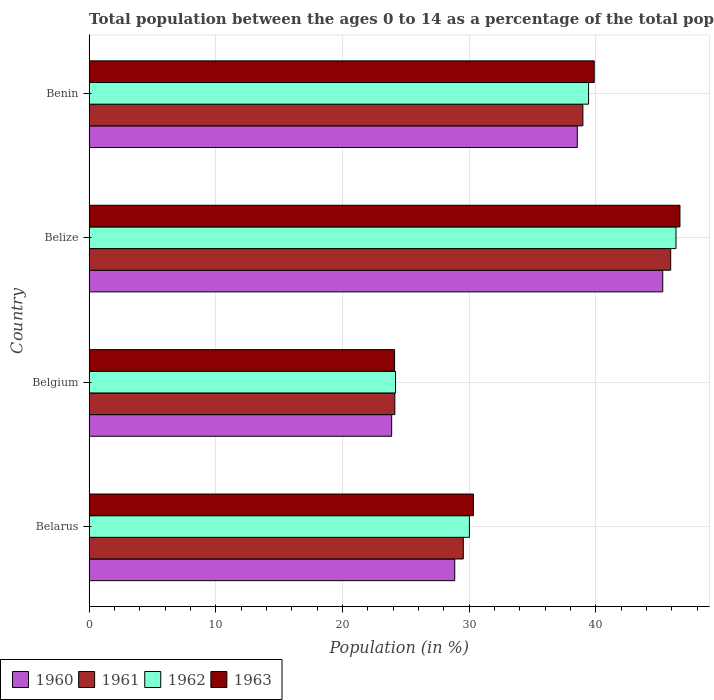How many groups of bars are there?
Your answer should be very brief. 4. Are the number of bars on each tick of the Y-axis equal?
Your response must be concise. Yes. How many bars are there on the 2nd tick from the top?
Make the answer very short. 4. What is the label of the 2nd group of bars from the top?
Make the answer very short. Belize. In how many cases, is the number of bars for a given country not equal to the number of legend labels?
Your answer should be very brief. 0. What is the percentage of the population ages 0 to 14 in 1960 in Belgium?
Ensure brevity in your answer.  23.88. Across all countries, what is the maximum percentage of the population ages 0 to 14 in 1961?
Your response must be concise. 45.9. Across all countries, what is the minimum percentage of the population ages 0 to 14 in 1961?
Your answer should be very brief. 24.13. In which country was the percentage of the population ages 0 to 14 in 1963 maximum?
Ensure brevity in your answer.  Belize. In which country was the percentage of the population ages 0 to 14 in 1960 minimum?
Make the answer very short. Belgium. What is the total percentage of the population ages 0 to 14 in 1963 in the graph?
Keep it short and to the point. 140.95. What is the difference between the percentage of the population ages 0 to 14 in 1960 in Belgium and that in Benin?
Your answer should be very brief. -14.65. What is the difference between the percentage of the population ages 0 to 14 in 1960 in Benin and the percentage of the population ages 0 to 14 in 1963 in Belize?
Your answer should be very brief. -8.1. What is the average percentage of the population ages 0 to 14 in 1962 per country?
Your answer should be very brief. 34.99. What is the difference between the percentage of the population ages 0 to 14 in 1961 and percentage of the population ages 0 to 14 in 1962 in Belarus?
Provide a short and direct response. -0.48. In how many countries, is the percentage of the population ages 0 to 14 in 1961 greater than 18 ?
Provide a short and direct response. 4. What is the ratio of the percentage of the population ages 0 to 14 in 1962 in Belize to that in Benin?
Offer a very short reply. 1.18. Is the percentage of the population ages 0 to 14 in 1962 in Belgium less than that in Benin?
Your response must be concise. Yes. Is the difference between the percentage of the population ages 0 to 14 in 1961 in Belgium and Benin greater than the difference between the percentage of the population ages 0 to 14 in 1962 in Belgium and Benin?
Your answer should be very brief. Yes. What is the difference between the highest and the second highest percentage of the population ages 0 to 14 in 1963?
Make the answer very short. 6.77. What is the difference between the highest and the lowest percentage of the population ages 0 to 14 in 1963?
Your answer should be compact. 22.52. Is the sum of the percentage of the population ages 0 to 14 in 1961 in Belarus and Benin greater than the maximum percentage of the population ages 0 to 14 in 1960 across all countries?
Your response must be concise. Yes. Is it the case that in every country, the sum of the percentage of the population ages 0 to 14 in 1963 and percentage of the population ages 0 to 14 in 1960 is greater than the sum of percentage of the population ages 0 to 14 in 1961 and percentage of the population ages 0 to 14 in 1962?
Give a very brief answer. No. What does the 4th bar from the bottom in Benin represents?
Offer a terse response. 1963. Is it the case that in every country, the sum of the percentage of the population ages 0 to 14 in 1963 and percentage of the population ages 0 to 14 in 1961 is greater than the percentage of the population ages 0 to 14 in 1960?
Offer a very short reply. Yes. How many bars are there?
Provide a succinct answer. 16. Are all the bars in the graph horizontal?
Provide a short and direct response. Yes. How many countries are there in the graph?
Make the answer very short. 4. Does the graph contain any zero values?
Ensure brevity in your answer.  No. Does the graph contain grids?
Give a very brief answer. Yes. Where does the legend appear in the graph?
Make the answer very short. Bottom left. What is the title of the graph?
Ensure brevity in your answer.  Total population between the ages 0 to 14 as a percentage of the total population. What is the label or title of the X-axis?
Offer a terse response. Population (in %). What is the label or title of the Y-axis?
Ensure brevity in your answer.  Country. What is the Population (in %) of 1960 in Belarus?
Offer a very short reply. 28.86. What is the Population (in %) of 1961 in Belarus?
Your answer should be compact. 29.54. What is the Population (in %) in 1962 in Belarus?
Keep it short and to the point. 30.02. What is the Population (in %) in 1963 in Belarus?
Provide a short and direct response. 30.34. What is the Population (in %) in 1960 in Belgium?
Give a very brief answer. 23.88. What is the Population (in %) in 1961 in Belgium?
Ensure brevity in your answer.  24.13. What is the Population (in %) of 1962 in Belgium?
Provide a succinct answer. 24.19. What is the Population (in %) of 1963 in Belgium?
Provide a short and direct response. 24.11. What is the Population (in %) of 1960 in Belize?
Give a very brief answer. 45.28. What is the Population (in %) of 1961 in Belize?
Provide a succinct answer. 45.9. What is the Population (in %) of 1962 in Belize?
Ensure brevity in your answer.  46.32. What is the Population (in %) in 1963 in Belize?
Keep it short and to the point. 46.63. What is the Population (in %) of 1960 in Benin?
Provide a succinct answer. 38.53. What is the Population (in %) in 1961 in Benin?
Your response must be concise. 38.97. What is the Population (in %) of 1962 in Benin?
Your answer should be compact. 39.42. What is the Population (in %) of 1963 in Benin?
Keep it short and to the point. 39.87. Across all countries, what is the maximum Population (in %) of 1960?
Provide a short and direct response. 45.28. Across all countries, what is the maximum Population (in %) of 1961?
Make the answer very short. 45.9. Across all countries, what is the maximum Population (in %) in 1962?
Offer a very short reply. 46.32. Across all countries, what is the maximum Population (in %) in 1963?
Make the answer very short. 46.63. Across all countries, what is the minimum Population (in %) in 1960?
Provide a short and direct response. 23.88. Across all countries, what is the minimum Population (in %) of 1961?
Make the answer very short. 24.13. Across all countries, what is the minimum Population (in %) in 1962?
Keep it short and to the point. 24.19. Across all countries, what is the minimum Population (in %) of 1963?
Offer a very short reply. 24.11. What is the total Population (in %) of 1960 in the graph?
Offer a very short reply. 136.55. What is the total Population (in %) in 1961 in the graph?
Ensure brevity in your answer.  138.54. What is the total Population (in %) of 1962 in the graph?
Keep it short and to the point. 139.95. What is the total Population (in %) in 1963 in the graph?
Provide a short and direct response. 140.95. What is the difference between the Population (in %) of 1960 in Belarus and that in Belgium?
Your answer should be very brief. 4.98. What is the difference between the Population (in %) in 1961 in Belarus and that in Belgium?
Provide a succinct answer. 5.41. What is the difference between the Population (in %) of 1962 in Belarus and that in Belgium?
Ensure brevity in your answer.  5.83. What is the difference between the Population (in %) in 1963 in Belarus and that in Belgium?
Make the answer very short. 6.22. What is the difference between the Population (in %) in 1960 in Belarus and that in Belize?
Your response must be concise. -16.41. What is the difference between the Population (in %) of 1961 in Belarus and that in Belize?
Offer a very short reply. -16.37. What is the difference between the Population (in %) in 1962 in Belarus and that in Belize?
Make the answer very short. -16.3. What is the difference between the Population (in %) in 1963 in Belarus and that in Belize?
Your response must be concise. -16.3. What is the difference between the Population (in %) in 1960 in Belarus and that in Benin?
Offer a terse response. -9.67. What is the difference between the Population (in %) of 1961 in Belarus and that in Benin?
Make the answer very short. -9.44. What is the difference between the Population (in %) of 1962 in Belarus and that in Benin?
Ensure brevity in your answer.  -9.4. What is the difference between the Population (in %) in 1963 in Belarus and that in Benin?
Ensure brevity in your answer.  -9.53. What is the difference between the Population (in %) of 1960 in Belgium and that in Belize?
Make the answer very short. -21.39. What is the difference between the Population (in %) in 1961 in Belgium and that in Belize?
Your response must be concise. -21.77. What is the difference between the Population (in %) in 1962 in Belgium and that in Belize?
Your answer should be compact. -22.14. What is the difference between the Population (in %) in 1963 in Belgium and that in Belize?
Give a very brief answer. -22.52. What is the difference between the Population (in %) of 1960 in Belgium and that in Benin?
Your answer should be very brief. -14.65. What is the difference between the Population (in %) of 1961 in Belgium and that in Benin?
Your answer should be compact. -14.84. What is the difference between the Population (in %) in 1962 in Belgium and that in Benin?
Your answer should be very brief. -15.24. What is the difference between the Population (in %) of 1963 in Belgium and that in Benin?
Offer a very short reply. -15.76. What is the difference between the Population (in %) in 1960 in Belize and that in Benin?
Provide a short and direct response. 6.74. What is the difference between the Population (in %) of 1961 in Belize and that in Benin?
Provide a succinct answer. 6.93. What is the difference between the Population (in %) in 1962 in Belize and that in Benin?
Offer a very short reply. 6.9. What is the difference between the Population (in %) in 1963 in Belize and that in Benin?
Your answer should be very brief. 6.77. What is the difference between the Population (in %) of 1960 in Belarus and the Population (in %) of 1961 in Belgium?
Your answer should be very brief. 4.73. What is the difference between the Population (in %) in 1960 in Belarus and the Population (in %) in 1962 in Belgium?
Keep it short and to the point. 4.67. What is the difference between the Population (in %) of 1960 in Belarus and the Population (in %) of 1963 in Belgium?
Provide a succinct answer. 4.75. What is the difference between the Population (in %) in 1961 in Belarus and the Population (in %) in 1962 in Belgium?
Give a very brief answer. 5.35. What is the difference between the Population (in %) in 1961 in Belarus and the Population (in %) in 1963 in Belgium?
Your answer should be very brief. 5.42. What is the difference between the Population (in %) in 1962 in Belarus and the Population (in %) in 1963 in Belgium?
Your response must be concise. 5.91. What is the difference between the Population (in %) of 1960 in Belarus and the Population (in %) of 1961 in Belize?
Your answer should be very brief. -17.04. What is the difference between the Population (in %) in 1960 in Belarus and the Population (in %) in 1962 in Belize?
Provide a succinct answer. -17.46. What is the difference between the Population (in %) in 1960 in Belarus and the Population (in %) in 1963 in Belize?
Make the answer very short. -17.77. What is the difference between the Population (in %) in 1961 in Belarus and the Population (in %) in 1962 in Belize?
Keep it short and to the point. -16.79. What is the difference between the Population (in %) in 1961 in Belarus and the Population (in %) in 1963 in Belize?
Your answer should be very brief. -17.1. What is the difference between the Population (in %) in 1962 in Belarus and the Population (in %) in 1963 in Belize?
Ensure brevity in your answer.  -16.62. What is the difference between the Population (in %) of 1960 in Belarus and the Population (in %) of 1961 in Benin?
Keep it short and to the point. -10.11. What is the difference between the Population (in %) in 1960 in Belarus and the Population (in %) in 1962 in Benin?
Give a very brief answer. -10.56. What is the difference between the Population (in %) of 1960 in Belarus and the Population (in %) of 1963 in Benin?
Your response must be concise. -11.01. What is the difference between the Population (in %) of 1961 in Belarus and the Population (in %) of 1962 in Benin?
Offer a terse response. -9.89. What is the difference between the Population (in %) of 1961 in Belarus and the Population (in %) of 1963 in Benin?
Provide a short and direct response. -10.33. What is the difference between the Population (in %) of 1962 in Belarus and the Population (in %) of 1963 in Benin?
Make the answer very short. -9.85. What is the difference between the Population (in %) of 1960 in Belgium and the Population (in %) of 1961 in Belize?
Your answer should be compact. -22.02. What is the difference between the Population (in %) of 1960 in Belgium and the Population (in %) of 1962 in Belize?
Your answer should be compact. -22.44. What is the difference between the Population (in %) in 1960 in Belgium and the Population (in %) in 1963 in Belize?
Provide a short and direct response. -22.75. What is the difference between the Population (in %) in 1961 in Belgium and the Population (in %) in 1962 in Belize?
Your answer should be very brief. -22.19. What is the difference between the Population (in %) of 1961 in Belgium and the Population (in %) of 1963 in Belize?
Keep it short and to the point. -22.5. What is the difference between the Population (in %) of 1962 in Belgium and the Population (in %) of 1963 in Belize?
Give a very brief answer. -22.45. What is the difference between the Population (in %) in 1960 in Belgium and the Population (in %) in 1961 in Benin?
Provide a succinct answer. -15.09. What is the difference between the Population (in %) of 1960 in Belgium and the Population (in %) of 1962 in Benin?
Your response must be concise. -15.54. What is the difference between the Population (in %) in 1960 in Belgium and the Population (in %) in 1963 in Benin?
Provide a short and direct response. -15.99. What is the difference between the Population (in %) of 1961 in Belgium and the Population (in %) of 1962 in Benin?
Your answer should be compact. -15.29. What is the difference between the Population (in %) in 1961 in Belgium and the Population (in %) in 1963 in Benin?
Offer a terse response. -15.74. What is the difference between the Population (in %) in 1962 in Belgium and the Population (in %) in 1963 in Benin?
Keep it short and to the point. -15.68. What is the difference between the Population (in %) in 1960 in Belize and the Population (in %) in 1961 in Benin?
Your answer should be very brief. 6.3. What is the difference between the Population (in %) in 1960 in Belize and the Population (in %) in 1962 in Benin?
Ensure brevity in your answer.  5.85. What is the difference between the Population (in %) in 1960 in Belize and the Population (in %) in 1963 in Benin?
Ensure brevity in your answer.  5.41. What is the difference between the Population (in %) of 1961 in Belize and the Population (in %) of 1962 in Benin?
Give a very brief answer. 6.48. What is the difference between the Population (in %) of 1961 in Belize and the Population (in %) of 1963 in Benin?
Your response must be concise. 6.03. What is the difference between the Population (in %) of 1962 in Belize and the Population (in %) of 1963 in Benin?
Provide a short and direct response. 6.45. What is the average Population (in %) of 1960 per country?
Give a very brief answer. 34.14. What is the average Population (in %) in 1961 per country?
Make the answer very short. 34.64. What is the average Population (in %) in 1962 per country?
Keep it short and to the point. 34.99. What is the average Population (in %) in 1963 per country?
Your answer should be very brief. 35.24. What is the difference between the Population (in %) of 1960 and Population (in %) of 1961 in Belarus?
Your answer should be very brief. -0.68. What is the difference between the Population (in %) in 1960 and Population (in %) in 1962 in Belarus?
Provide a short and direct response. -1.16. What is the difference between the Population (in %) in 1960 and Population (in %) in 1963 in Belarus?
Offer a terse response. -1.48. What is the difference between the Population (in %) of 1961 and Population (in %) of 1962 in Belarus?
Provide a short and direct response. -0.48. What is the difference between the Population (in %) in 1961 and Population (in %) in 1963 in Belarus?
Offer a very short reply. -0.8. What is the difference between the Population (in %) of 1962 and Population (in %) of 1963 in Belarus?
Ensure brevity in your answer.  -0.32. What is the difference between the Population (in %) in 1960 and Population (in %) in 1961 in Belgium?
Give a very brief answer. -0.25. What is the difference between the Population (in %) in 1960 and Population (in %) in 1962 in Belgium?
Give a very brief answer. -0.31. What is the difference between the Population (in %) in 1960 and Population (in %) in 1963 in Belgium?
Give a very brief answer. -0.23. What is the difference between the Population (in %) of 1961 and Population (in %) of 1962 in Belgium?
Give a very brief answer. -0.06. What is the difference between the Population (in %) in 1961 and Population (in %) in 1963 in Belgium?
Provide a succinct answer. 0.02. What is the difference between the Population (in %) in 1962 and Population (in %) in 1963 in Belgium?
Give a very brief answer. 0.07. What is the difference between the Population (in %) in 1960 and Population (in %) in 1961 in Belize?
Offer a very short reply. -0.63. What is the difference between the Population (in %) in 1960 and Population (in %) in 1962 in Belize?
Provide a succinct answer. -1.05. What is the difference between the Population (in %) of 1960 and Population (in %) of 1963 in Belize?
Provide a succinct answer. -1.36. What is the difference between the Population (in %) in 1961 and Population (in %) in 1962 in Belize?
Your answer should be compact. -0.42. What is the difference between the Population (in %) in 1961 and Population (in %) in 1963 in Belize?
Make the answer very short. -0.73. What is the difference between the Population (in %) in 1962 and Population (in %) in 1963 in Belize?
Keep it short and to the point. -0.31. What is the difference between the Population (in %) of 1960 and Population (in %) of 1961 in Benin?
Offer a terse response. -0.44. What is the difference between the Population (in %) in 1960 and Population (in %) in 1962 in Benin?
Give a very brief answer. -0.89. What is the difference between the Population (in %) of 1960 and Population (in %) of 1963 in Benin?
Give a very brief answer. -1.34. What is the difference between the Population (in %) of 1961 and Population (in %) of 1962 in Benin?
Your answer should be compact. -0.45. What is the difference between the Population (in %) of 1961 and Population (in %) of 1963 in Benin?
Provide a short and direct response. -0.9. What is the difference between the Population (in %) of 1962 and Population (in %) of 1963 in Benin?
Offer a very short reply. -0.45. What is the ratio of the Population (in %) of 1960 in Belarus to that in Belgium?
Offer a terse response. 1.21. What is the ratio of the Population (in %) in 1961 in Belarus to that in Belgium?
Ensure brevity in your answer.  1.22. What is the ratio of the Population (in %) of 1962 in Belarus to that in Belgium?
Your answer should be compact. 1.24. What is the ratio of the Population (in %) of 1963 in Belarus to that in Belgium?
Offer a terse response. 1.26. What is the ratio of the Population (in %) of 1960 in Belarus to that in Belize?
Give a very brief answer. 0.64. What is the ratio of the Population (in %) in 1961 in Belarus to that in Belize?
Your answer should be very brief. 0.64. What is the ratio of the Population (in %) of 1962 in Belarus to that in Belize?
Provide a succinct answer. 0.65. What is the ratio of the Population (in %) in 1963 in Belarus to that in Belize?
Provide a succinct answer. 0.65. What is the ratio of the Population (in %) in 1960 in Belarus to that in Benin?
Make the answer very short. 0.75. What is the ratio of the Population (in %) of 1961 in Belarus to that in Benin?
Make the answer very short. 0.76. What is the ratio of the Population (in %) in 1962 in Belarus to that in Benin?
Ensure brevity in your answer.  0.76. What is the ratio of the Population (in %) in 1963 in Belarus to that in Benin?
Your response must be concise. 0.76. What is the ratio of the Population (in %) of 1960 in Belgium to that in Belize?
Give a very brief answer. 0.53. What is the ratio of the Population (in %) in 1961 in Belgium to that in Belize?
Make the answer very short. 0.53. What is the ratio of the Population (in %) of 1962 in Belgium to that in Belize?
Provide a succinct answer. 0.52. What is the ratio of the Population (in %) of 1963 in Belgium to that in Belize?
Offer a terse response. 0.52. What is the ratio of the Population (in %) of 1960 in Belgium to that in Benin?
Offer a very short reply. 0.62. What is the ratio of the Population (in %) in 1961 in Belgium to that in Benin?
Provide a succinct answer. 0.62. What is the ratio of the Population (in %) of 1962 in Belgium to that in Benin?
Offer a terse response. 0.61. What is the ratio of the Population (in %) of 1963 in Belgium to that in Benin?
Offer a terse response. 0.6. What is the ratio of the Population (in %) in 1960 in Belize to that in Benin?
Your answer should be compact. 1.18. What is the ratio of the Population (in %) of 1961 in Belize to that in Benin?
Make the answer very short. 1.18. What is the ratio of the Population (in %) in 1962 in Belize to that in Benin?
Offer a terse response. 1.18. What is the ratio of the Population (in %) in 1963 in Belize to that in Benin?
Keep it short and to the point. 1.17. What is the difference between the highest and the second highest Population (in %) in 1960?
Make the answer very short. 6.74. What is the difference between the highest and the second highest Population (in %) in 1961?
Your answer should be very brief. 6.93. What is the difference between the highest and the second highest Population (in %) of 1962?
Offer a very short reply. 6.9. What is the difference between the highest and the second highest Population (in %) of 1963?
Provide a short and direct response. 6.77. What is the difference between the highest and the lowest Population (in %) of 1960?
Your answer should be compact. 21.39. What is the difference between the highest and the lowest Population (in %) of 1961?
Keep it short and to the point. 21.77. What is the difference between the highest and the lowest Population (in %) of 1962?
Your answer should be compact. 22.14. What is the difference between the highest and the lowest Population (in %) of 1963?
Your answer should be very brief. 22.52. 